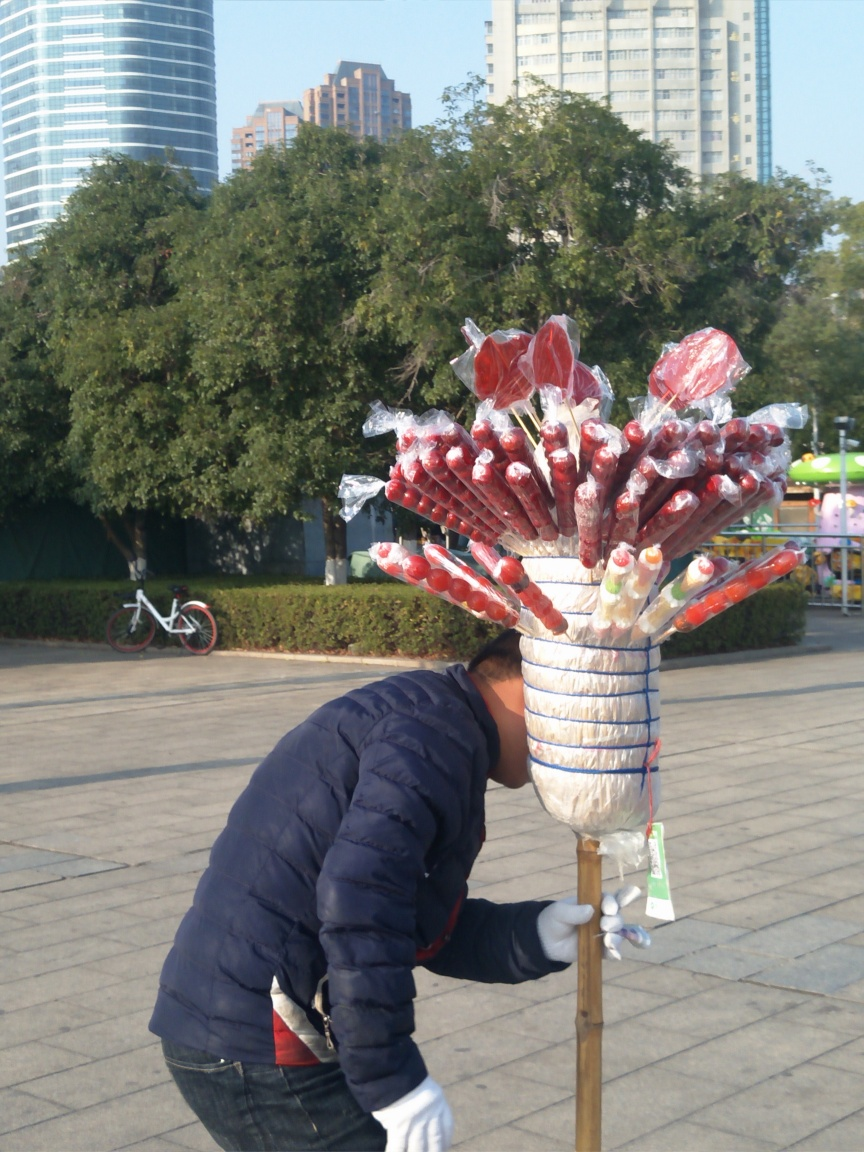Are the subjects well-distinguished from the background? The subjects are moderately distinguished from the background. The individual in the foreground is bending over and slightly blurred, which may affect the clarity of the distinction. However, the colorful candy apples on the stand they tend to separate from the urban park setting behind them, due to their bright colors and plastic wrapping that catches the light. 